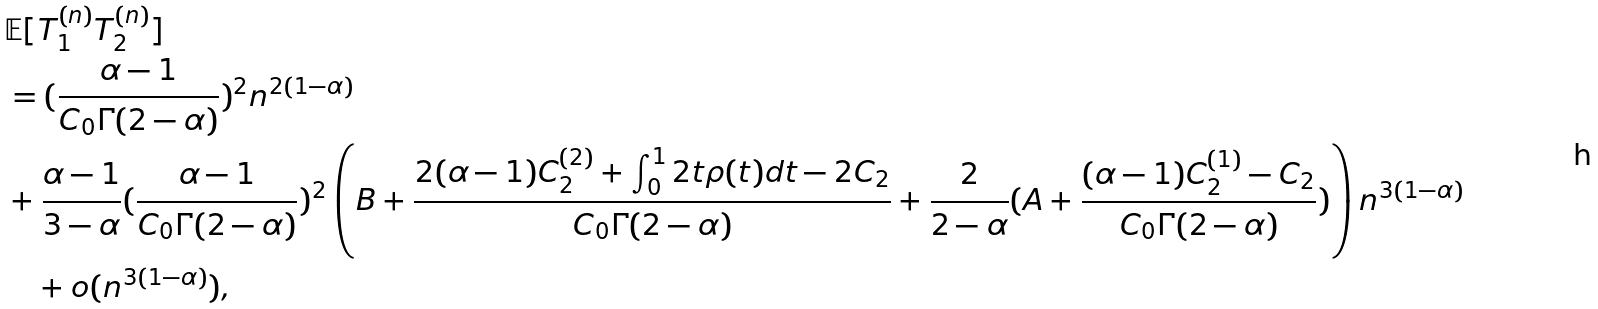<formula> <loc_0><loc_0><loc_500><loc_500>& \mathbb { E } [ T _ { 1 } ^ { ( n ) } T _ { 2 } ^ { ( n ) } ] \\ & = ( \frac { \alpha - 1 } { C _ { 0 } \Gamma ( 2 - \alpha ) } ) ^ { 2 } n ^ { 2 ( 1 - \alpha ) } \\ & + \frac { \alpha - 1 } { 3 - \alpha } ( \frac { \alpha - 1 } { C _ { 0 } \Gamma ( 2 - \alpha ) } ) ^ { 2 } \left ( B + \frac { 2 ( \alpha - 1 ) C _ { 2 } ^ { ( 2 ) } + \int _ { 0 } ^ { 1 } 2 t \rho ( t ) d t - 2 C _ { 2 } } { C _ { 0 } \Gamma ( 2 - \alpha ) } + \frac { 2 } { 2 - \alpha } ( A + \frac { ( \alpha - 1 ) C _ { 2 } ^ { ( 1 ) } - C _ { 2 } } { C _ { 0 } \Gamma ( 2 - \alpha ) } ) \right ) n ^ { 3 ( 1 - \alpha ) } \\ & \quad + o ( n ^ { 3 ( 1 - \alpha ) } ) , \\</formula> 